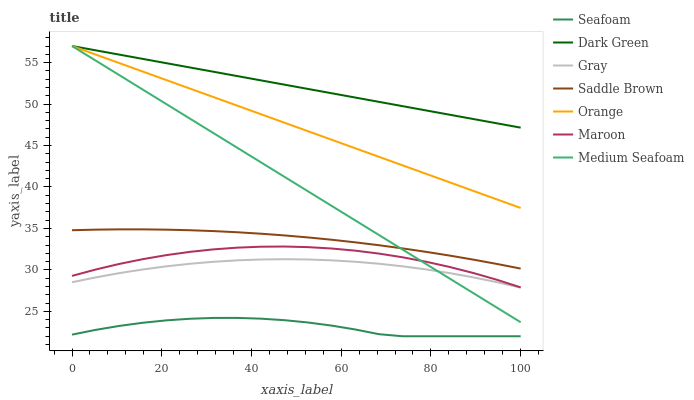Does Seafoam have the minimum area under the curve?
Answer yes or no. Yes. Does Dark Green have the maximum area under the curve?
Answer yes or no. Yes. Does Maroon have the minimum area under the curve?
Answer yes or no. No. Does Maroon have the maximum area under the curve?
Answer yes or no. No. Is Orange the smoothest?
Answer yes or no. Yes. Is Seafoam the roughest?
Answer yes or no. Yes. Is Maroon the smoothest?
Answer yes or no. No. Is Maroon the roughest?
Answer yes or no. No. Does Seafoam have the lowest value?
Answer yes or no. Yes. Does Maroon have the lowest value?
Answer yes or no. No. Does Dark Green have the highest value?
Answer yes or no. Yes. Does Maroon have the highest value?
Answer yes or no. No. Is Seafoam less than Gray?
Answer yes or no. Yes. Is Dark Green greater than Saddle Brown?
Answer yes or no. Yes. Does Maroon intersect Medium Seafoam?
Answer yes or no. Yes. Is Maroon less than Medium Seafoam?
Answer yes or no. No. Is Maroon greater than Medium Seafoam?
Answer yes or no. No. Does Seafoam intersect Gray?
Answer yes or no. No. 